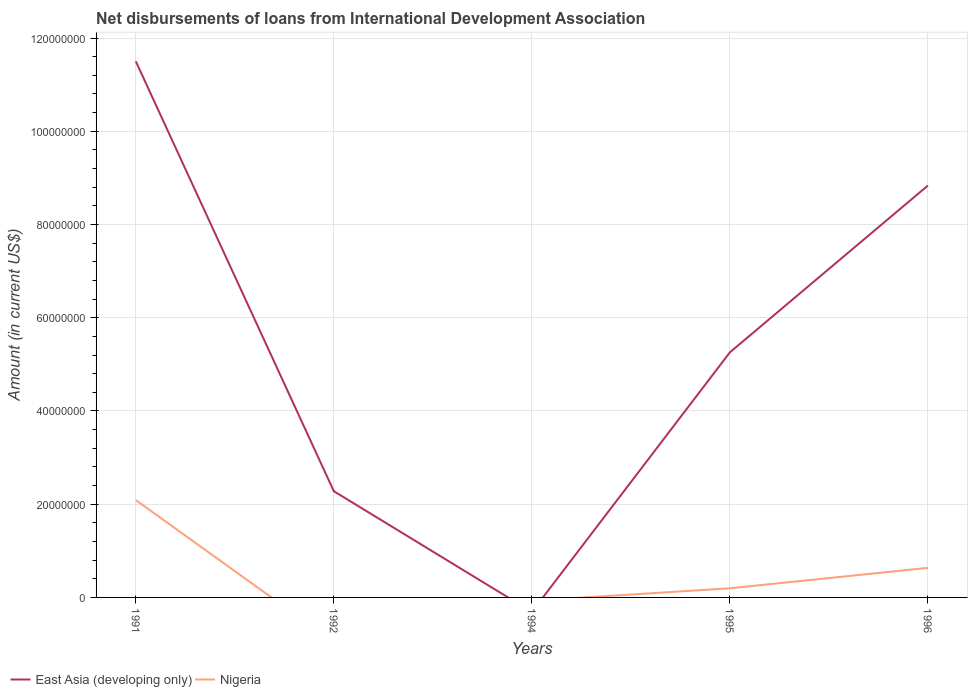How many different coloured lines are there?
Make the answer very short. 2. What is the total amount of loans disbursed in East Asia (developing only) in the graph?
Your answer should be very brief. 6.24e+07. What is the difference between the highest and the second highest amount of loans disbursed in East Asia (developing only)?
Provide a short and direct response. 1.15e+08. What is the difference between the highest and the lowest amount of loans disbursed in Nigeria?
Give a very brief answer. 2. Is the amount of loans disbursed in East Asia (developing only) strictly greater than the amount of loans disbursed in Nigeria over the years?
Provide a short and direct response. No. Are the values on the major ticks of Y-axis written in scientific E-notation?
Provide a short and direct response. No. Does the graph contain grids?
Keep it short and to the point. Yes. How are the legend labels stacked?
Make the answer very short. Horizontal. What is the title of the graph?
Make the answer very short. Net disbursements of loans from International Development Association. Does "Guatemala" appear as one of the legend labels in the graph?
Your answer should be very brief. No. What is the Amount (in current US$) of East Asia (developing only) in 1991?
Provide a succinct answer. 1.15e+08. What is the Amount (in current US$) in Nigeria in 1991?
Provide a short and direct response. 2.09e+07. What is the Amount (in current US$) in East Asia (developing only) in 1992?
Provide a short and direct response. 2.28e+07. What is the Amount (in current US$) in East Asia (developing only) in 1994?
Offer a very short reply. 0. What is the Amount (in current US$) of Nigeria in 1994?
Provide a short and direct response. 0. What is the Amount (in current US$) in East Asia (developing only) in 1995?
Offer a very short reply. 5.26e+07. What is the Amount (in current US$) of Nigeria in 1995?
Keep it short and to the point. 1.96e+06. What is the Amount (in current US$) of East Asia (developing only) in 1996?
Keep it short and to the point. 8.84e+07. What is the Amount (in current US$) of Nigeria in 1996?
Keep it short and to the point. 6.34e+06. Across all years, what is the maximum Amount (in current US$) of East Asia (developing only)?
Keep it short and to the point. 1.15e+08. Across all years, what is the maximum Amount (in current US$) of Nigeria?
Your response must be concise. 2.09e+07. What is the total Amount (in current US$) of East Asia (developing only) in the graph?
Offer a terse response. 2.79e+08. What is the total Amount (in current US$) of Nigeria in the graph?
Offer a very short reply. 2.92e+07. What is the difference between the Amount (in current US$) in East Asia (developing only) in 1991 and that in 1992?
Keep it short and to the point. 9.22e+07. What is the difference between the Amount (in current US$) in East Asia (developing only) in 1991 and that in 1995?
Give a very brief answer. 6.24e+07. What is the difference between the Amount (in current US$) in Nigeria in 1991 and that in 1995?
Offer a terse response. 1.89e+07. What is the difference between the Amount (in current US$) in East Asia (developing only) in 1991 and that in 1996?
Your answer should be very brief. 2.67e+07. What is the difference between the Amount (in current US$) of Nigeria in 1991 and that in 1996?
Ensure brevity in your answer.  1.45e+07. What is the difference between the Amount (in current US$) of East Asia (developing only) in 1992 and that in 1995?
Ensure brevity in your answer.  -2.98e+07. What is the difference between the Amount (in current US$) in East Asia (developing only) in 1992 and that in 1996?
Keep it short and to the point. -6.56e+07. What is the difference between the Amount (in current US$) in East Asia (developing only) in 1995 and that in 1996?
Your response must be concise. -3.58e+07. What is the difference between the Amount (in current US$) of Nigeria in 1995 and that in 1996?
Offer a very short reply. -4.38e+06. What is the difference between the Amount (in current US$) of East Asia (developing only) in 1991 and the Amount (in current US$) of Nigeria in 1995?
Give a very brief answer. 1.13e+08. What is the difference between the Amount (in current US$) of East Asia (developing only) in 1991 and the Amount (in current US$) of Nigeria in 1996?
Make the answer very short. 1.09e+08. What is the difference between the Amount (in current US$) of East Asia (developing only) in 1992 and the Amount (in current US$) of Nigeria in 1995?
Make the answer very short. 2.08e+07. What is the difference between the Amount (in current US$) of East Asia (developing only) in 1992 and the Amount (in current US$) of Nigeria in 1996?
Provide a short and direct response. 1.64e+07. What is the difference between the Amount (in current US$) of East Asia (developing only) in 1995 and the Amount (in current US$) of Nigeria in 1996?
Offer a very short reply. 4.62e+07. What is the average Amount (in current US$) in East Asia (developing only) per year?
Keep it short and to the point. 5.57e+07. What is the average Amount (in current US$) of Nigeria per year?
Ensure brevity in your answer.  5.84e+06. In the year 1991, what is the difference between the Amount (in current US$) of East Asia (developing only) and Amount (in current US$) of Nigeria?
Ensure brevity in your answer.  9.41e+07. In the year 1995, what is the difference between the Amount (in current US$) of East Asia (developing only) and Amount (in current US$) of Nigeria?
Your answer should be compact. 5.06e+07. In the year 1996, what is the difference between the Amount (in current US$) in East Asia (developing only) and Amount (in current US$) in Nigeria?
Ensure brevity in your answer.  8.20e+07. What is the ratio of the Amount (in current US$) in East Asia (developing only) in 1991 to that in 1992?
Your answer should be very brief. 5.05. What is the ratio of the Amount (in current US$) of East Asia (developing only) in 1991 to that in 1995?
Ensure brevity in your answer.  2.19. What is the ratio of the Amount (in current US$) in Nigeria in 1991 to that in 1995?
Offer a terse response. 10.64. What is the ratio of the Amount (in current US$) of East Asia (developing only) in 1991 to that in 1996?
Offer a terse response. 1.3. What is the ratio of the Amount (in current US$) of Nigeria in 1991 to that in 1996?
Give a very brief answer. 3.29. What is the ratio of the Amount (in current US$) in East Asia (developing only) in 1992 to that in 1995?
Keep it short and to the point. 0.43. What is the ratio of the Amount (in current US$) of East Asia (developing only) in 1992 to that in 1996?
Provide a succinct answer. 0.26. What is the ratio of the Amount (in current US$) of East Asia (developing only) in 1995 to that in 1996?
Offer a terse response. 0.59. What is the ratio of the Amount (in current US$) of Nigeria in 1995 to that in 1996?
Your answer should be compact. 0.31. What is the difference between the highest and the second highest Amount (in current US$) of East Asia (developing only)?
Your response must be concise. 2.67e+07. What is the difference between the highest and the second highest Amount (in current US$) of Nigeria?
Keep it short and to the point. 1.45e+07. What is the difference between the highest and the lowest Amount (in current US$) in East Asia (developing only)?
Your response must be concise. 1.15e+08. What is the difference between the highest and the lowest Amount (in current US$) of Nigeria?
Your answer should be very brief. 2.09e+07. 